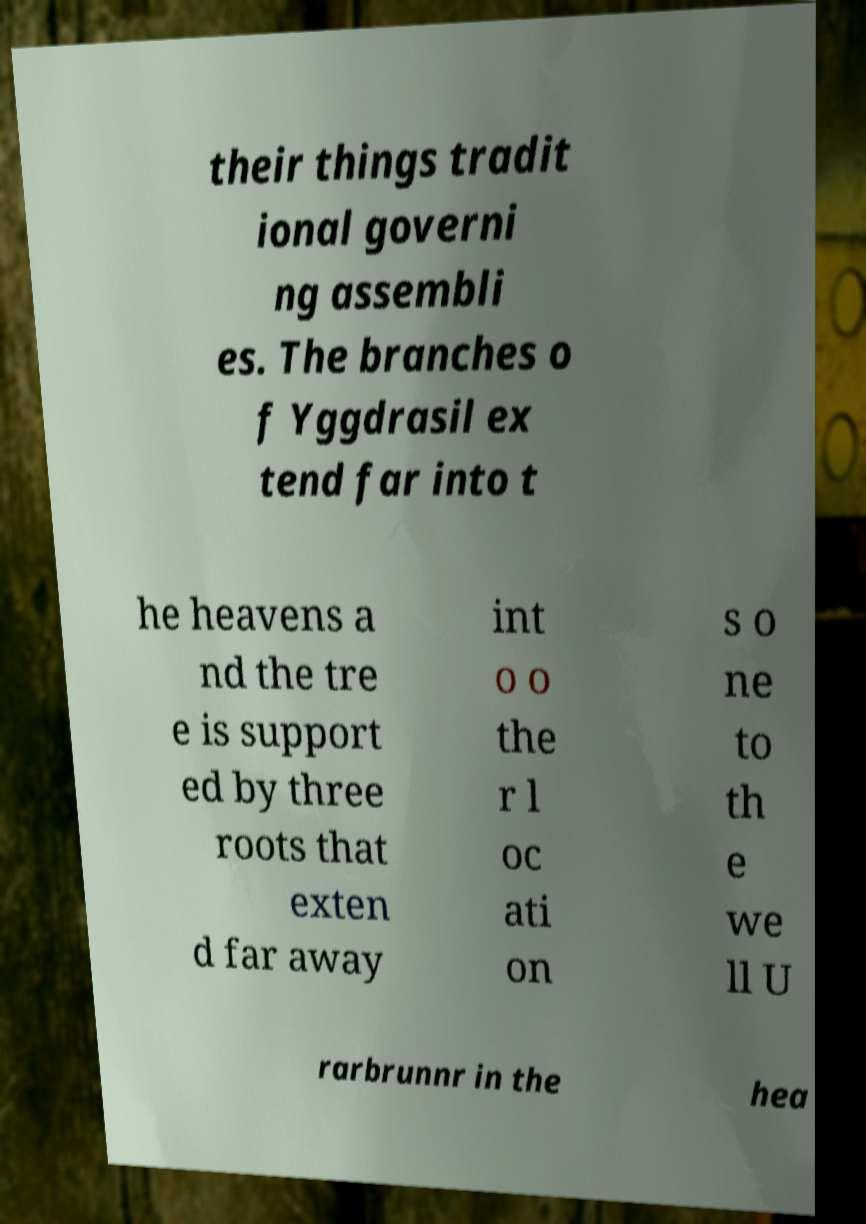Can you read and provide the text displayed in the image?This photo seems to have some interesting text. Can you extract and type it out for me? their things tradit ional governi ng assembli es. The branches o f Yggdrasil ex tend far into t he heavens a nd the tre e is support ed by three roots that exten d far away int o o the r l oc ati on s o ne to th e we ll U rarbrunnr in the hea 